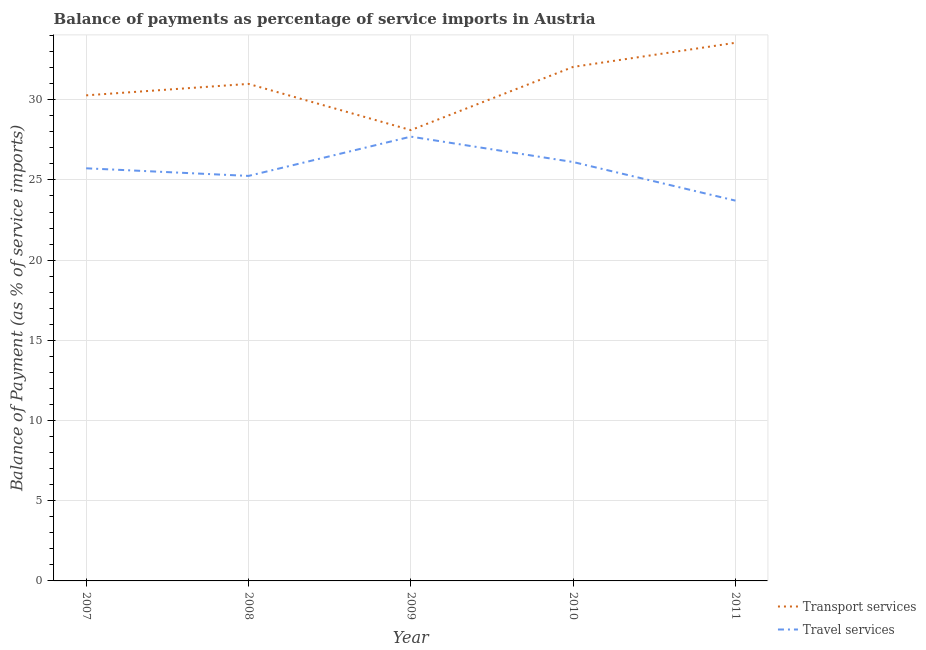Does the line corresponding to balance of payments of travel services intersect with the line corresponding to balance of payments of transport services?
Make the answer very short. No. What is the balance of payments of transport services in 2010?
Give a very brief answer. 32.05. Across all years, what is the maximum balance of payments of transport services?
Make the answer very short. 33.55. Across all years, what is the minimum balance of payments of transport services?
Make the answer very short. 28.11. In which year was the balance of payments of travel services minimum?
Your response must be concise. 2011. What is the total balance of payments of travel services in the graph?
Keep it short and to the point. 128.5. What is the difference between the balance of payments of transport services in 2007 and that in 2009?
Your answer should be very brief. 2.17. What is the difference between the balance of payments of transport services in 2011 and the balance of payments of travel services in 2009?
Your response must be concise. 5.85. What is the average balance of payments of travel services per year?
Your answer should be compact. 25.7. In the year 2010, what is the difference between the balance of payments of travel services and balance of payments of transport services?
Give a very brief answer. -5.93. What is the ratio of the balance of payments of transport services in 2008 to that in 2011?
Offer a very short reply. 0.92. Is the balance of payments of travel services in 2008 less than that in 2010?
Provide a short and direct response. Yes. Is the difference between the balance of payments of travel services in 2007 and 2011 greater than the difference between the balance of payments of transport services in 2007 and 2011?
Offer a very short reply. Yes. What is the difference between the highest and the second highest balance of payments of travel services?
Make the answer very short. 1.58. What is the difference between the highest and the lowest balance of payments of travel services?
Your response must be concise. 3.99. Does the balance of payments of travel services monotonically increase over the years?
Provide a short and direct response. No. How many lines are there?
Keep it short and to the point. 2. Are the values on the major ticks of Y-axis written in scientific E-notation?
Provide a succinct answer. No. Does the graph contain any zero values?
Provide a succinct answer. No. Where does the legend appear in the graph?
Offer a terse response. Bottom right. What is the title of the graph?
Give a very brief answer. Balance of payments as percentage of service imports in Austria. What is the label or title of the Y-axis?
Provide a short and direct response. Balance of Payment (as % of service imports). What is the Balance of Payment (as % of service imports) of Transport services in 2007?
Provide a short and direct response. 30.27. What is the Balance of Payment (as % of service imports) of Travel services in 2007?
Your answer should be very brief. 25.73. What is the Balance of Payment (as % of service imports) in Transport services in 2008?
Your response must be concise. 30.99. What is the Balance of Payment (as % of service imports) of Travel services in 2008?
Your response must be concise. 25.25. What is the Balance of Payment (as % of service imports) of Transport services in 2009?
Offer a terse response. 28.11. What is the Balance of Payment (as % of service imports) in Travel services in 2009?
Your answer should be compact. 27.7. What is the Balance of Payment (as % of service imports) of Transport services in 2010?
Give a very brief answer. 32.05. What is the Balance of Payment (as % of service imports) in Travel services in 2010?
Your answer should be compact. 26.12. What is the Balance of Payment (as % of service imports) in Transport services in 2011?
Provide a short and direct response. 33.55. What is the Balance of Payment (as % of service imports) in Travel services in 2011?
Your response must be concise. 23.71. Across all years, what is the maximum Balance of Payment (as % of service imports) in Transport services?
Offer a terse response. 33.55. Across all years, what is the maximum Balance of Payment (as % of service imports) of Travel services?
Your answer should be very brief. 27.7. Across all years, what is the minimum Balance of Payment (as % of service imports) in Transport services?
Your answer should be very brief. 28.11. Across all years, what is the minimum Balance of Payment (as % of service imports) in Travel services?
Provide a short and direct response. 23.71. What is the total Balance of Payment (as % of service imports) in Transport services in the graph?
Offer a terse response. 154.97. What is the total Balance of Payment (as % of service imports) in Travel services in the graph?
Give a very brief answer. 128.5. What is the difference between the Balance of Payment (as % of service imports) in Transport services in 2007 and that in 2008?
Give a very brief answer. -0.71. What is the difference between the Balance of Payment (as % of service imports) of Travel services in 2007 and that in 2008?
Ensure brevity in your answer.  0.47. What is the difference between the Balance of Payment (as % of service imports) of Transport services in 2007 and that in 2009?
Your response must be concise. 2.17. What is the difference between the Balance of Payment (as % of service imports) in Travel services in 2007 and that in 2009?
Keep it short and to the point. -1.97. What is the difference between the Balance of Payment (as % of service imports) in Transport services in 2007 and that in 2010?
Keep it short and to the point. -1.77. What is the difference between the Balance of Payment (as % of service imports) in Travel services in 2007 and that in 2010?
Your response must be concise. -0.39. What is the difference between the Balance of Payment (as % of service imports) in Transport services in 2007 and that in 2011?
Ensure brevity in your answer.  -3.28. What is the difference between the Balance of Payment (as % of service imports) of Travel services in 2007 and that in 2011?
Ensure brevity in your answer.  2.02. What is the difference between the Balance of Payment (as % of service imports) of Transport services in 2008 and that in 2009?
Provide a succinct answer. 2.88. What is the difference between the Balance of Payment (as % of service imports) of Travel services in 2008 and that in 2009?
Give a very brief answer. -2.45. What is the difference between the Balance of Payment (as % of service imports) of Transport services in 2008 and that in 2010?
Provide a short and direct response. -1.06. What is the difference between the Balance of Payment (as % of service imports) in Travel services in 2008 and that in 2010?
Make the answer very short. -0.87. What is the difference between the Balance of Payment (as % of service imports) in Transport services in 2008 and that in 2011?
Your answer should be compact. -2.56. What is the difference between the Balance of Payment (as % of service imports) of Travel services in 2008 and that in 2011?
Offer a very short reply. 1.54. What is the difference between the Balance of Payment (as % of service imports) in Transport services in 2009 and that in 2010?
Your answer should be compact. -3.94. What is the difference between the Balance of Payment (as % of service imports) of Travel services in 2009 and that in 2010?
Offer a terse response. 1.58. What is the difference between the Balance of Payment (as % of service imports) of Transport services in 2009 and that in 2011?
Make the answer very short. -5.45. What is the difference between the Balance of Payment (as % of service imports) in Travel services in 2009 and that in 2011?
Offer a very short reply. 3.99. What is the difference between the Balance of Payment (as % of service imports) of Transport services in 2010 and that in 2011?
Offer a very short reply. -1.5. What is the difference between the Balance of Payment (as % of service imports) in Travel services in 2010 and that in 2011?
Make the answer very short. 2.41. What is the difference between the Balance of Payment (as % of service imports) in Transport services in 2007 and the Balance of Payment (as % of service imports) in Travel services in 2008?
Provide a short and direct response. 5.02. What is the difference between the Balance of Payment (as % of service imports) of Transport services in 2007 and the Balance of Payment (as % of service imports) of Travel services in 2009?
Your answer should be compact. 2.58. What is the difference between the Balance of Payment (as % of service imports) in Transport services in 2007 and the Balance of Payment (as % of service imports) in Travel services in 2010?
Ensure brevity in your answer.  4.16. What is the difference between the Balance of Payment (as % of service imports) in Transport services in 2007 and the Balance of Payment (as % of service imports) in Travel services in 2011?
Offer a terse response. 6.56. What is the difference between the Balance of Payment (as % of service imports) in Transport services in 2008 and the Balance of Payment (as % of service imports) in Travel services in 2009?
Offer a terse response. 3.29. What is the difference between the Balance of Payment (as % of service imports) in Transport services in 2008 and the Balance of Payment (as % of service imports) in Travel services in 2010?
Offer a terse response. 4.87. What is the difference between the Balance of Payment (as % of service imports) in Transport services in 2008 and the Balance of Payment (as % of service imports) in Travel services in 2011?
Provide a short and direct response. 7.28. What is the difference between the Balance of Payment (as % of service imports) of Transport services in 2009 and the Balance of Payment (as % of service imports) of Travel services in 2010?
Keep it short and to the point. 1.99. What is the difference between the Balance of Payment (as % of service imports) of Transport services in 2009 and the Balance of Payment (as % of service imports) of Travel services in 2011?
Keep it short and to the point. 4.4. What is the difference between the Balance of Payment (as % of service imports) in Transport services in 2010 and the Balance of Payment (as % of service imports) in Travel services in 2011?
Provide a succinct answer. 8.34. What is the average Balance of Payment (as % of service imports) in Transport services per year?
Offer a very short reply. 30.99. What is the average Balance of Payment (as % of service imports) in Travel services per year?
Your answer should be very brief. 25.7. In the year 2007, what is the difference between the Balance of Payment (as % of service imports) of Transport services and Balance of Payment (as % of service imports) of Travel services?
Ensure brevity in your answer.  4.55. In the year 2008, what is the difference between the Balance of Payment (as % of service imports) in Transport services and Balance of Payment (as % of service imports) in Travel services?
Offer a terse response. 5.74. In the year 2009, what is the difference between the Balance of Payment (as % of service imports) of Transport services and Balance of Payment (as % of service imports) of Travel services?
Provide a succinct answer. 0.41. In the year 2010, what is the difference between the Balance of Payment (as % of service imports) in Transport services and Balance of Payment (as % of service imports) in Travel services?
Your answer should be compact. 5.93. In the year 2011, what is the difference between the Balance of Payment (as % of service imports) of Transport services and Balance of Payment (as % of service imports) of Travel services?
Your response must be concise. 9.84. What is the ratio of the Balance of Payment (as % of service imports) in Transport services in 2007 to that in 2008?
Offer a very short reply. 0.98. What is the ratio of the Balance of Payment (as % of service imports) in Travel services in 2007 to that in 2008?
Offer a terse response. 1.02. What is the ratio of the Balance of Payment (as % of service imports) of Transport services in 2007 to that in 2009?
Keep it short and to the point. 1.08. What is the ratio of the Balance of Payment (as % of service imports) in Travel services in 2007 to that in 2009?
Provide a short and direct response. 0.93. What is the ratio of the Balance of Payment (as % of service imports) in Transport services in 2007 to that in 2010?
Keep it short and to the point. 0.94. What is the ratio of the Balance of Payment (as % of service imports) in Transport services in 2007 to that in 2011?
Keep it short and to the point. 0.9. What is the ratio of the Balance of Payment (as % of service imports) of Travel services in 2007 to that in 2011?
Your response must be concise. 1.08. What is the ratio of the Balance of Payment (as % of service imports) in Transport services in 2008 to that in 2009?
Your answer should be very brief. 1.1. What is the ratio of the Balance of Payment (as % of service imports) in Travel services in 2008 to that in 2009?
Your response must be concise. 0.91. What is the ratio of the Balance of Payment (as % of service imports) in Transport services in 2008 to that in 2010?
Your answer should be compact. 0.97. What is the ratio of the Balance of Payment (as % of service imports) of Travel services in 2008 to that in 2010?
Give a very brief answer. 0.97. What is the ratio of the Balance of Payment (as % of service imports) in Transport services in 2008 to that in 2011?
Ensure brevity in your answer.  0.92. What is the ratio of the Balance of Payment (as % of service imports) of Travel services in 2008 to that in 2011?
Offer a terse response. 1.06. What is the ratio of the Balance of Payment (as % of service imports) in Transport services in 2009 to that in 2010?
Offer a terse response. 0.88. What is the ratio of the Balance of Payment (as % of service imports) in Travel services in 2009 to that in 2010?
Keep it short and to the point. 1.06. What is the ratio of the Balance of Payment (as % of service imports) of Transport services in 2009 to that in 2011?
Keep it short and to the point. 0.84. What is the ratio of the Balance of Payment (as % of service imports) in Travel services in 2009 to that in 2011?
Offer a terse response. 1.17. What is the ratio of the Balance of Payment (as % of service imports) of Transport services in 2010 to that in 2011?
Your response must be concise. 0.96. What is the ratio of the Balance of Payment (as % of service imports) in Travel services in 2010 to that in 2011?
Your response must be concise. 1.1. What is the difference between the highest and the second highest Balance of Payment (as % of service imports) of Transport services?
Your answer should be compact. 1.5. What is the difference between the highest and the second highest Balance of Payment (as % of service imports) in Travel services?
Provide a short and direct response. 1.58. What is the difference between the highest and the lowest Balance of Payment (as % of service imports) in Transport services?
Make the answer very short. 5.45. What is the difference between the highest and the lowest Balance of Payment (as % of service imports) in Travel services?
Your answer should be very brief. 3.99. 